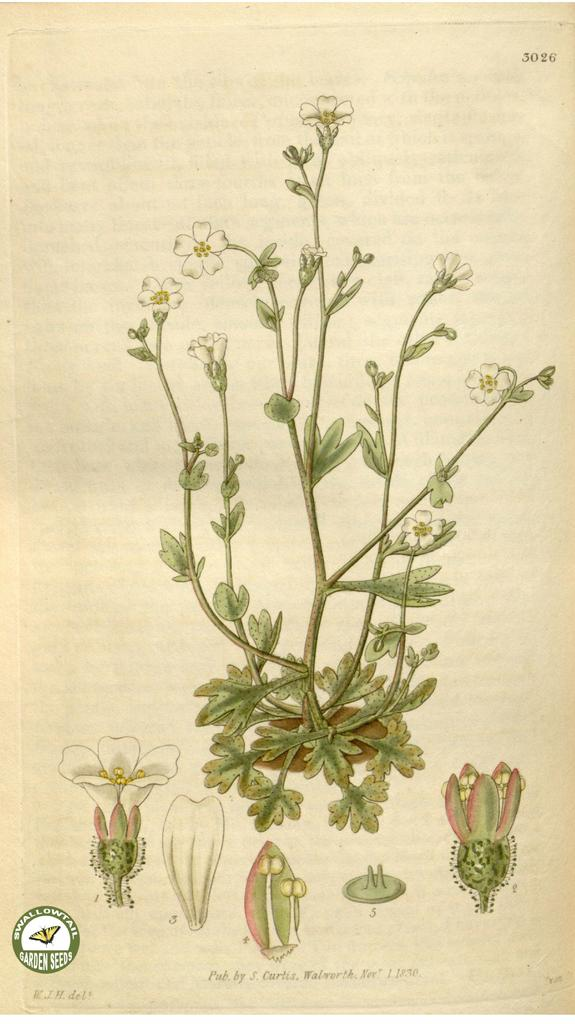What is depicted in the image? There is a diagram of a plant in the image. What is the diagram drawn on? The diagram is on a piece of paper. Can you describe the color of the paper? The paper is cream-colored. What color is the plant in the diagram? The plant in the diagram is green. What type of knife is being used to cut the car in the image? There is no knife or car present in the image; it features a diagram of a plant on a piece of paper. 